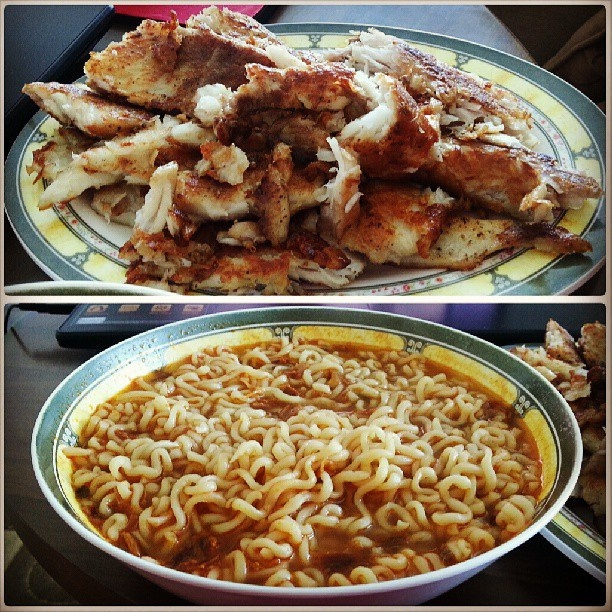Describe the objects in this image and their specific colors. I can see dining table in gray, black, brown, maroon, and tan tones, dining table in gray, maroon, black, darkgray, and tan tones, bowl in gray, ivory, black, and darkgray tones, and remote in gray, black, and darkblue tones in this image. 